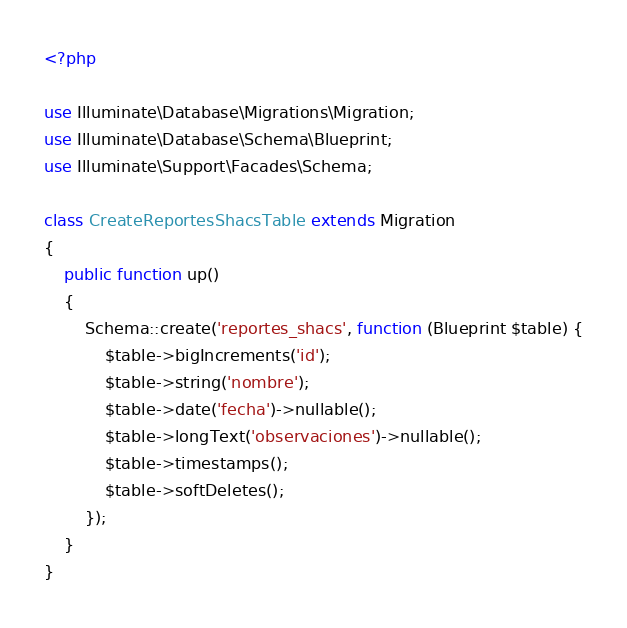Convert code to text. <code><loc_0><loc_0><loc_500><loc_500><_PHP_><?php

use Illuminate\Database\Migrations\Migration;
use Illuminate\Database\Schema\Blueprint;
use Illuminate\Support\Facades\Schema;

class CreateReportesShacsTable extends Migration
{
    public function up()
    {
        Schema::create('reportes_shacs', function (Blueprint $table) {
            $table->bigIncrements('id');
            $table->string('nombre');
            $table->date('fecha')->nullable();
            $table->longText('observaciones')->nullable();
            $table->timestamps();
            $table->softDeletes();
        });
    }
}
</code> 